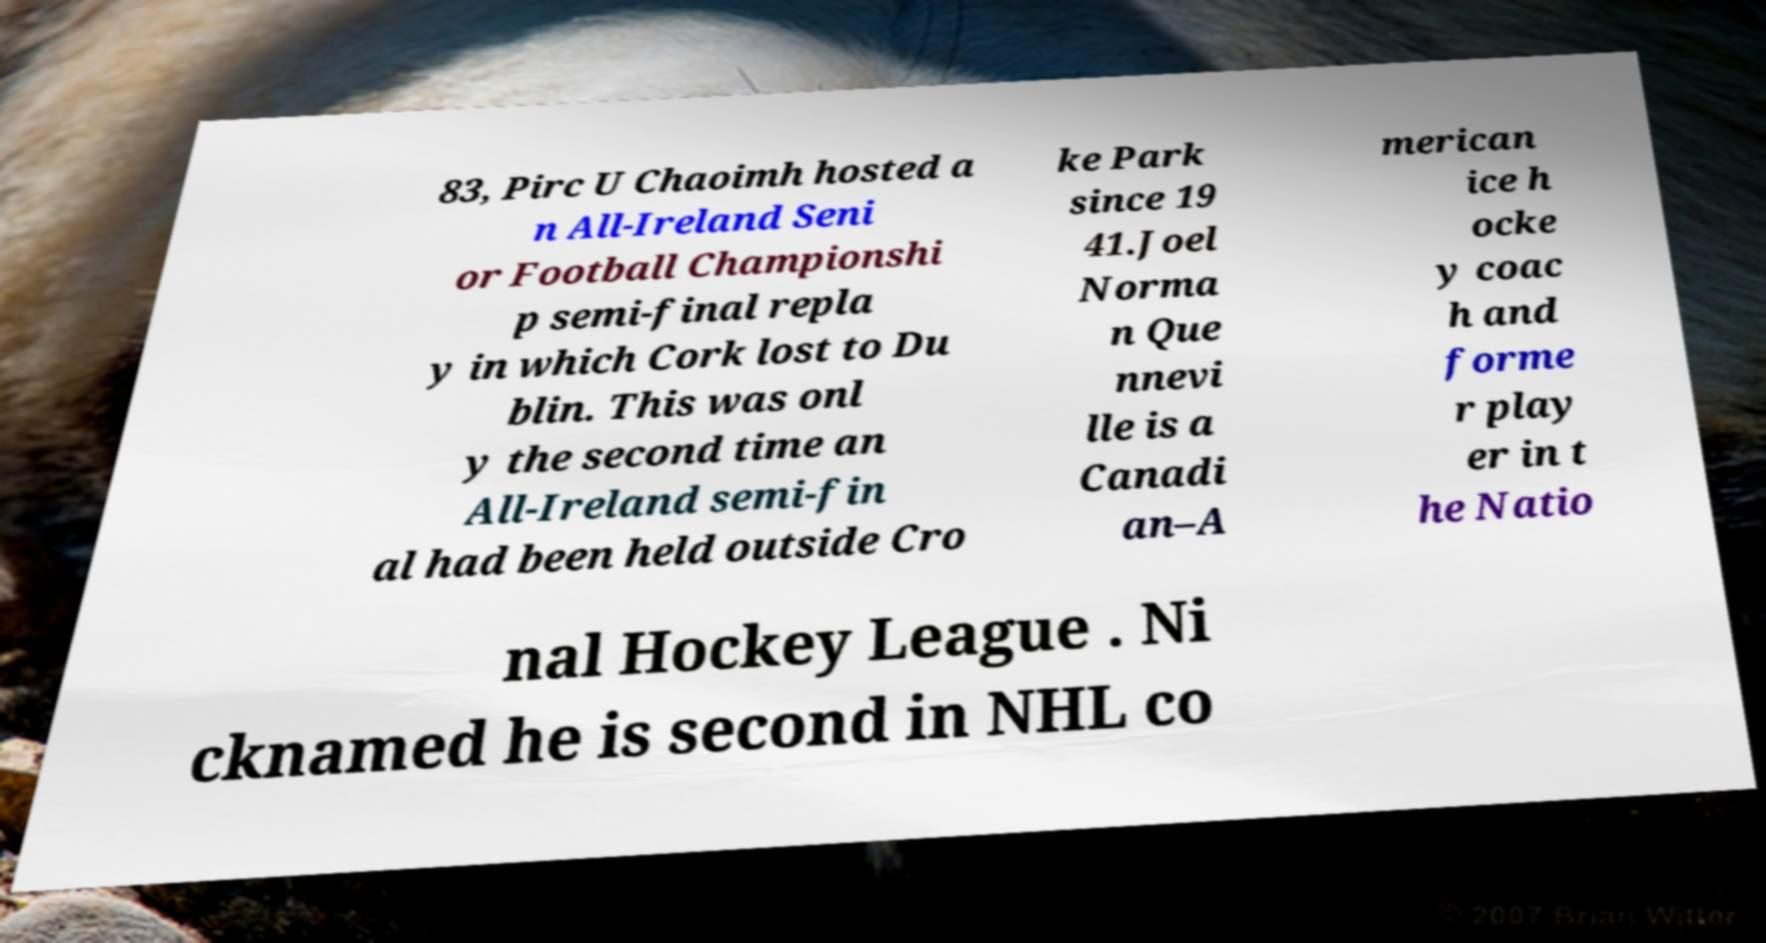Could you extract and type out the text from this image? 83, Pirc U Chaoimh hosted a n All-Ireland Seni or Football Championshi p semi-final repla y in which Cork lost to Du blin. This was onl y the second time an All-Ireland semi-fin al had been held outside Cro ke Park since 19 41.Joel Norma n Que nnevi lle is a Canadi an–A merican ice h ocke y coac h and forme r play er in t he Natio nal Hockey League . Ni cknamed he is second in NHL co 